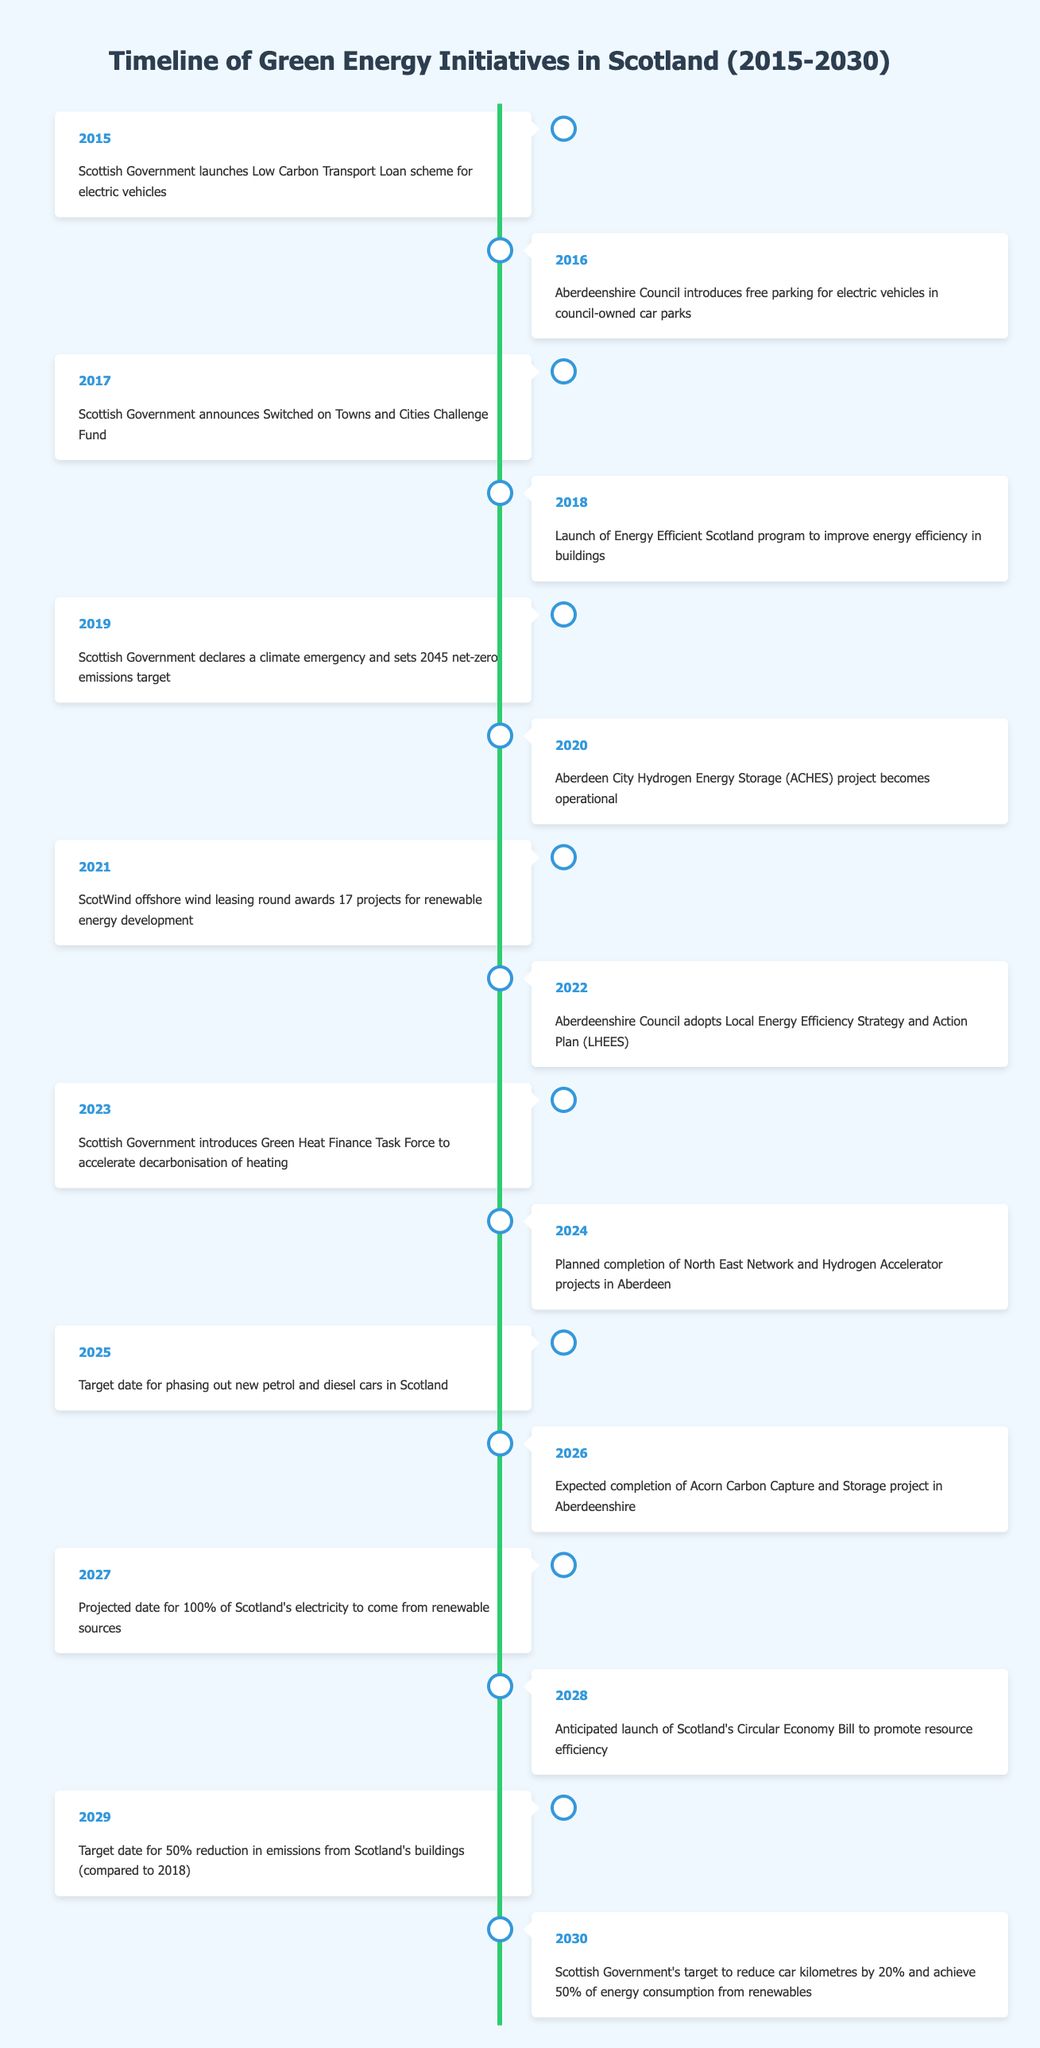What event took place in 2016? According to the table, in 2016, Aberdeenshire Council introduced free parking for electric vehicles in council-owned car parks.
Answer: Aberdeenshire Council introduces free parking for electric vehicles in council-owned car parks What is the target date for phasing out new petrol and diesel cars in Scotland? The table states that the target date for phasing out new petrol and diesel cars in Scotland is set for 2025.
Answer: 2025 Has the Scottish Government declared a climate emergency? From the timeline, it is clear that in 2019, the Scottish Government declared a climate emergency.
Answer: Yes How many projects were awarded in the ScotWind offshore wind leasing round in 2021? The timeline indicates that in 2021, 17 projects were awarded for renewable energy development in the ScotWind offshore wind leasing round.
Answer: 17 In what year is the expected completion of the Acorn Carbon Capture and Storage project in Aberdeenshire? The table reveals that the expected completion of the Acorn Carbon Capture and Storage project in Aberdeenshire is in 2026.
Answer: 2026 What events happened between 2021 and 2023? To find events between 2021 and 2023, we look at the table and see that in 2021, the ScotWind offshore wind leasing round awarded 17 projects, in 2022, Aberdeenshire Council adopted a Local Energy Efficiency Strategy and Action Plan, and in 2023, the Scottish Government introduced a Green Heat Finance Task Force.
Answer: ScotWind offshore wind leasing round awards 17 projects, Aberdeenshire Council adopts LHEES, Green Heat Finance Task Force introduced Will Scotland achieve 100% of its electricity from renewable sources by 2027? The table projects that by 2027, 100% of Scotland's electricity will come from renewable sources, suggesting a commitment to this goal.
Answer: Yes What is the relationship between the target date for reducing emissions from Scotland's buildings and the anticipated launch of Scotland's Circular Economy Bill? According to the table, the target date for a 50% reduction in emissions from buildings is set for 2029, and the anticipated launch of Scotland's Circular Economy Bill is in 2028. Thus, the Circular Economy Bill will likely help achieve the emissions reduction target shortly after its launch.
Answer: The Circular Economy Bill is anticipated to aid in achieving the emissions reduction by 2029 What is the projected date for 100% of Scotland's electricity to come from renewable sources? The table provides that the projected date for achieving 100% of Scotland's electricity from renewable sources is 2027.
Answer: 2027 